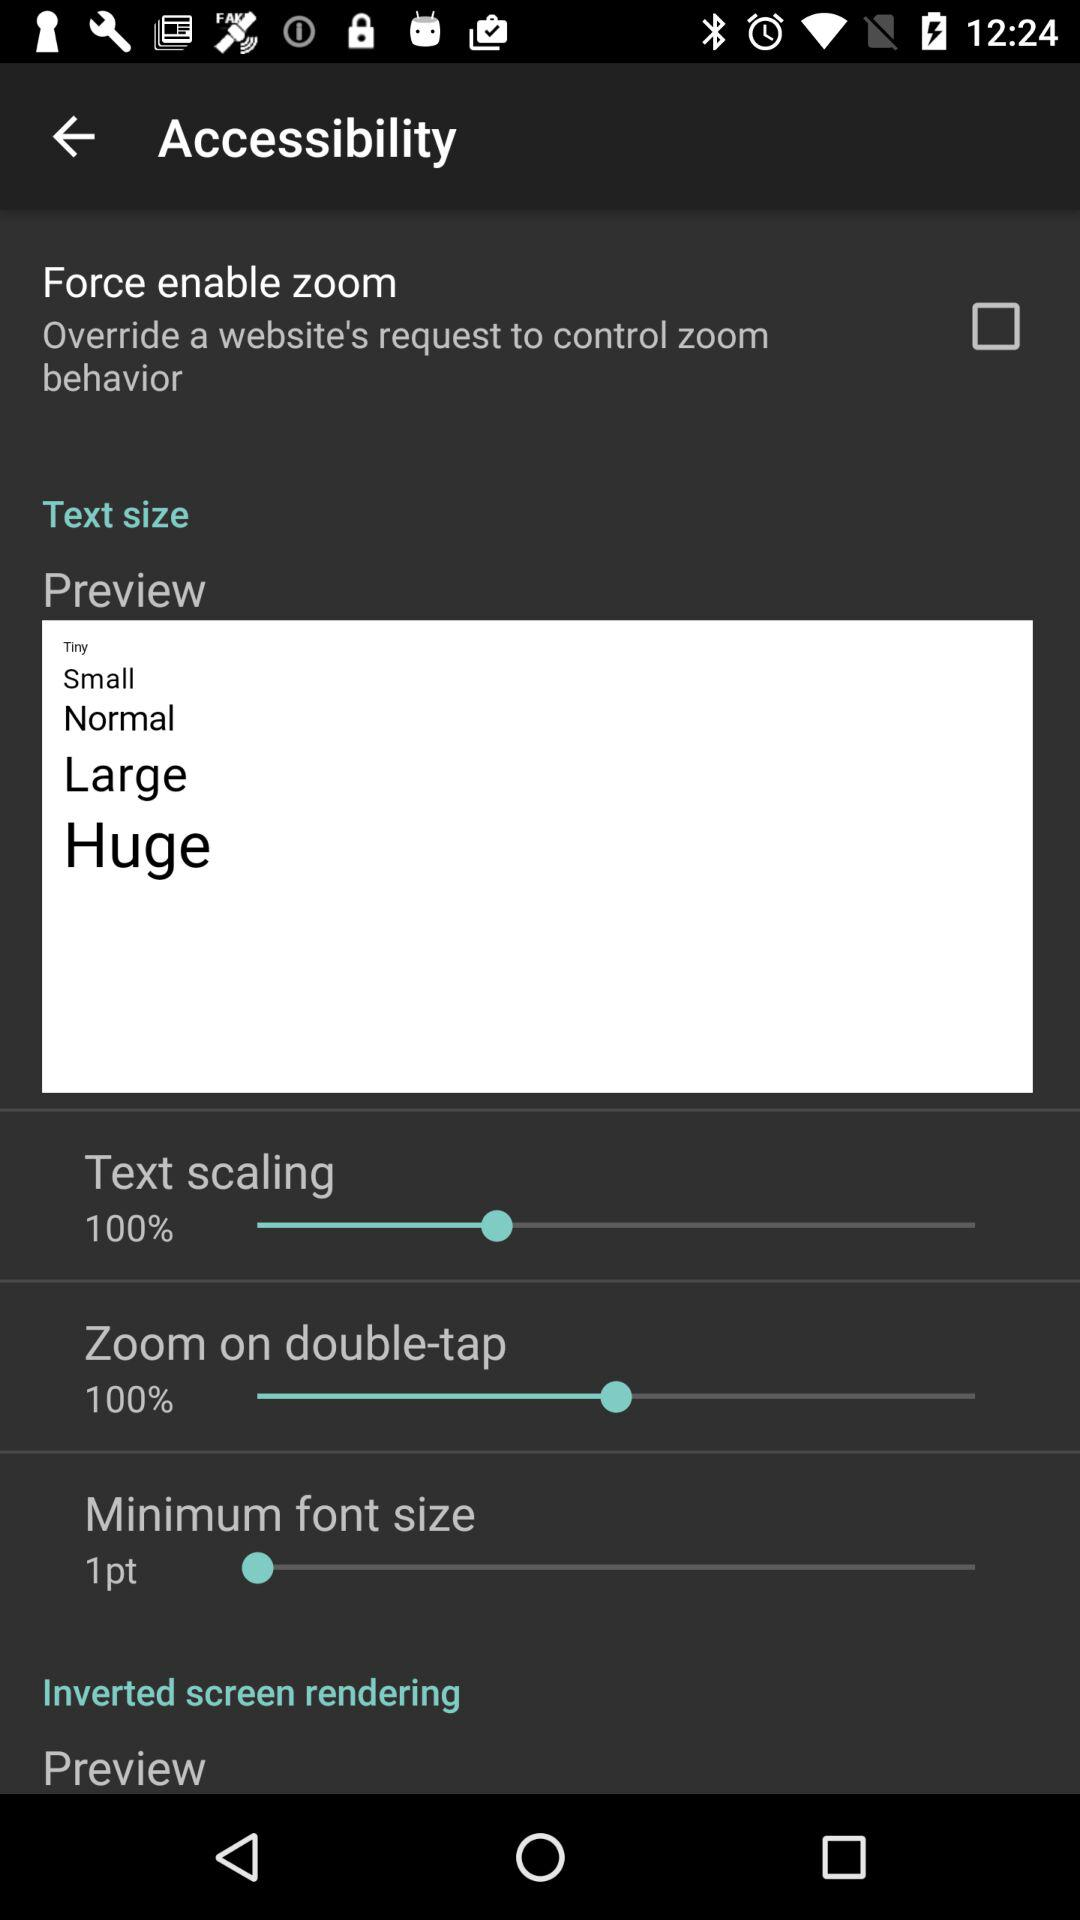What is the status of "Force enable zoom"? The status is "off". 